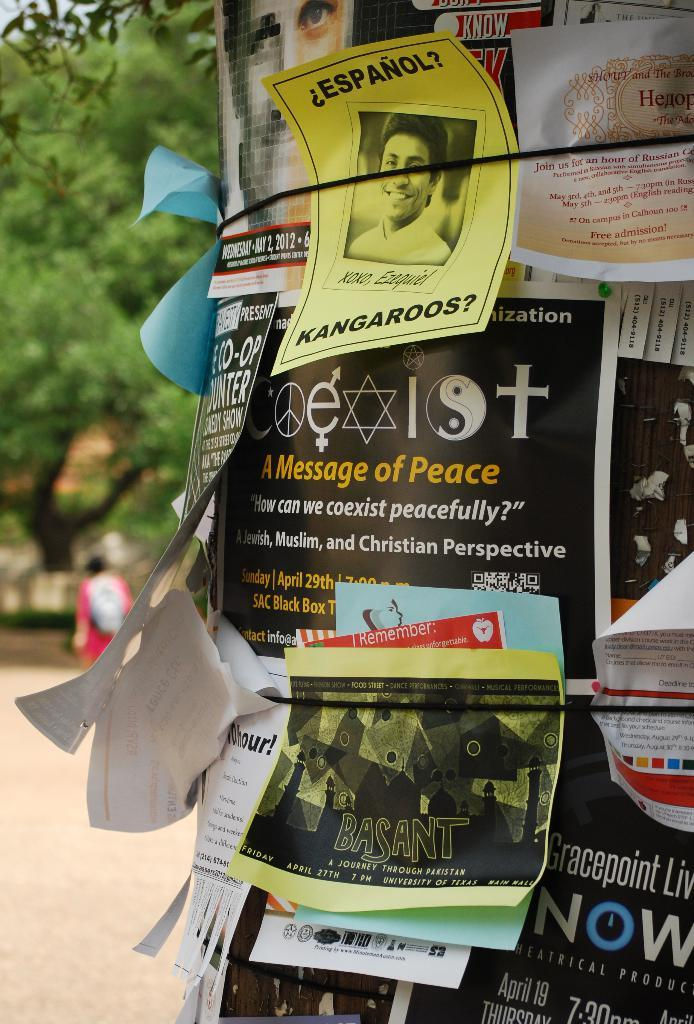<image>
Provide a brief description of the given image. Numerous signs on a pole, one reads A message of Peace. 